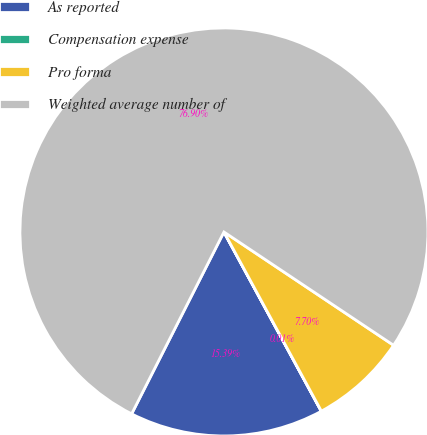<chart> <loc_0><loc_0><loc_500><loc_500><pie_chart><fcel>As reported<fcel>Compensation expense<fcel>Pro forma<fcel>Weighted average number of<nl><fcel>15.39%<fcel>0.01%<fcel>7.7%<fcel>76.9%<nl></chart> 